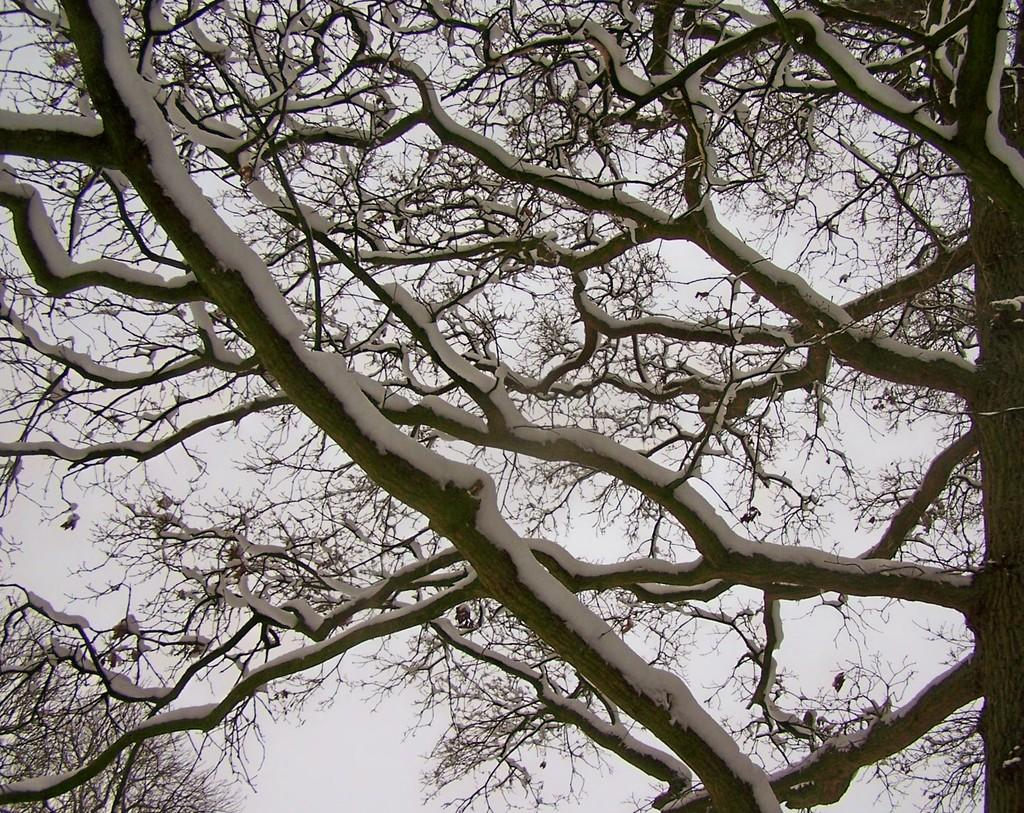What type of vegetation can be seen in the image? There are trees in the image. What is covering the trees in the image? The trees are covered with snow. What is visible in the background of the image? The sky is visible in the image. What type of wing can be seen on the trees in the image? There are no wings present on the trees in the image; they are covered with snow. What type of bait is used for fishing in the image? There is no fishing or bait present in the image; it features trees covered with snow and a visible sky. 